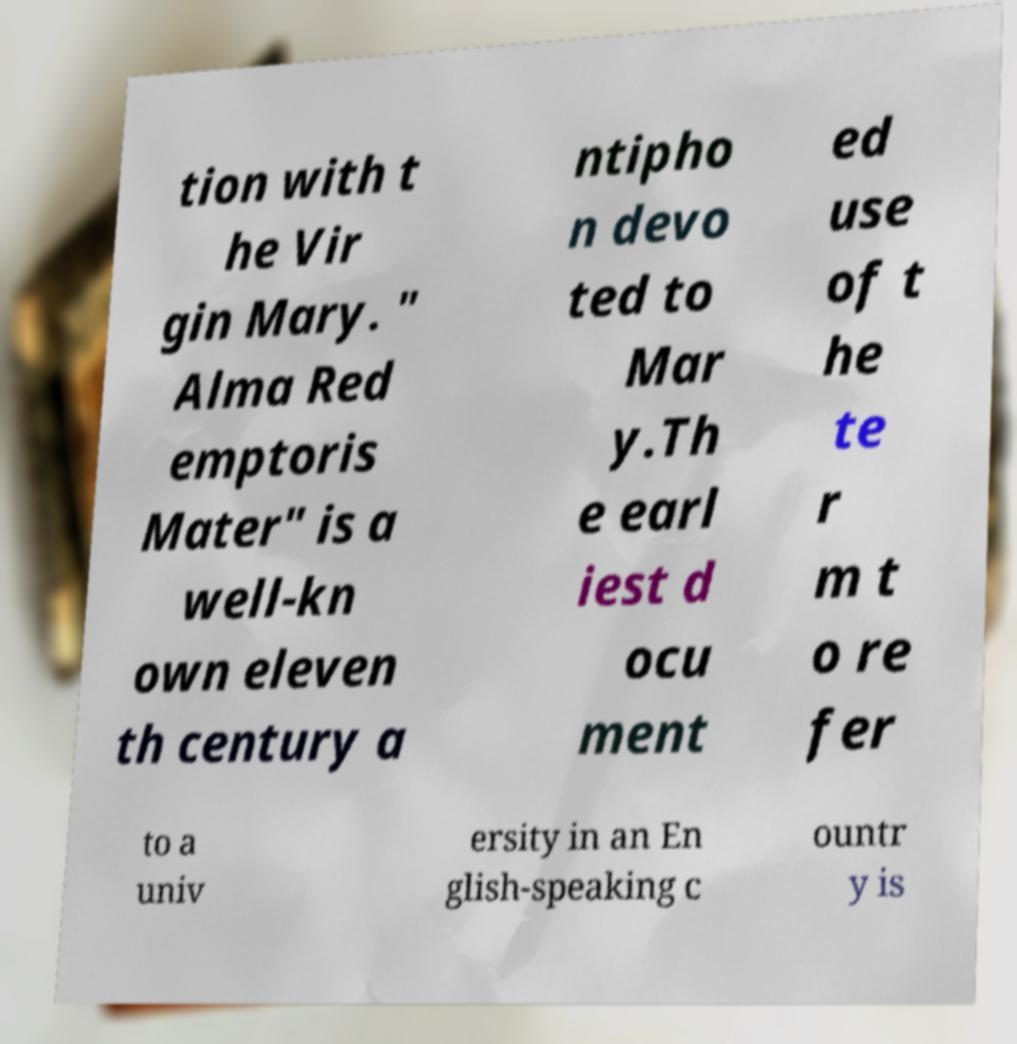Could you assist in decoding the text presented in this image and type it out clearly? tion with t he Vir gin Mary. " Alma Red emptoris Mater" is a well-kn own eleven th century a ntipho n devo ted to Mar y.Th e earl iest d ocu ment ed use of t he te r m t o re fer to a univ ersity in an En glish-speaking c ountr y is 